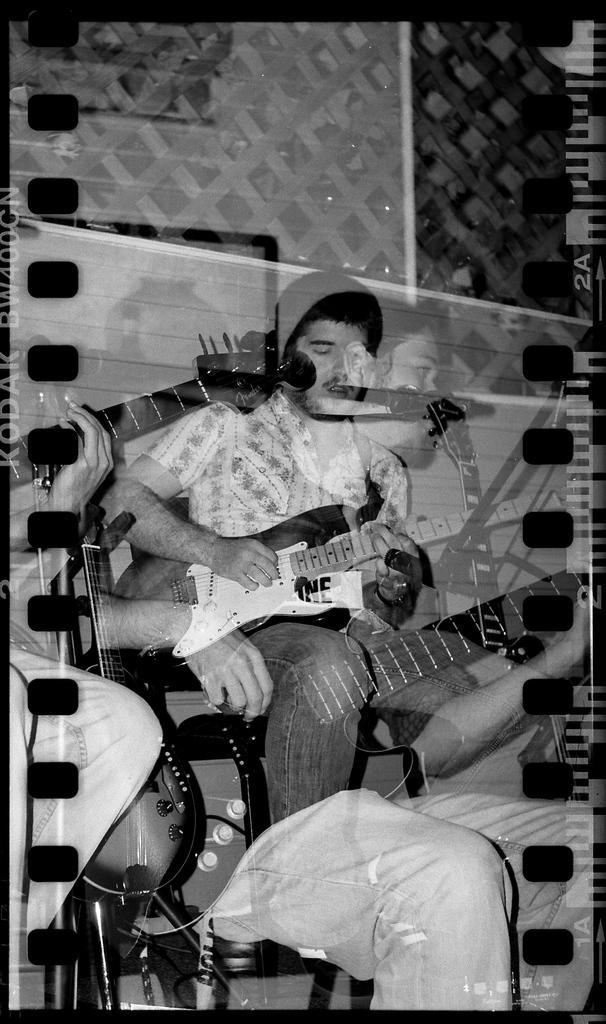Could you give a brief overview of what you see in this image? In this picture I can see a man is playing the guitar, it is an edited image. 